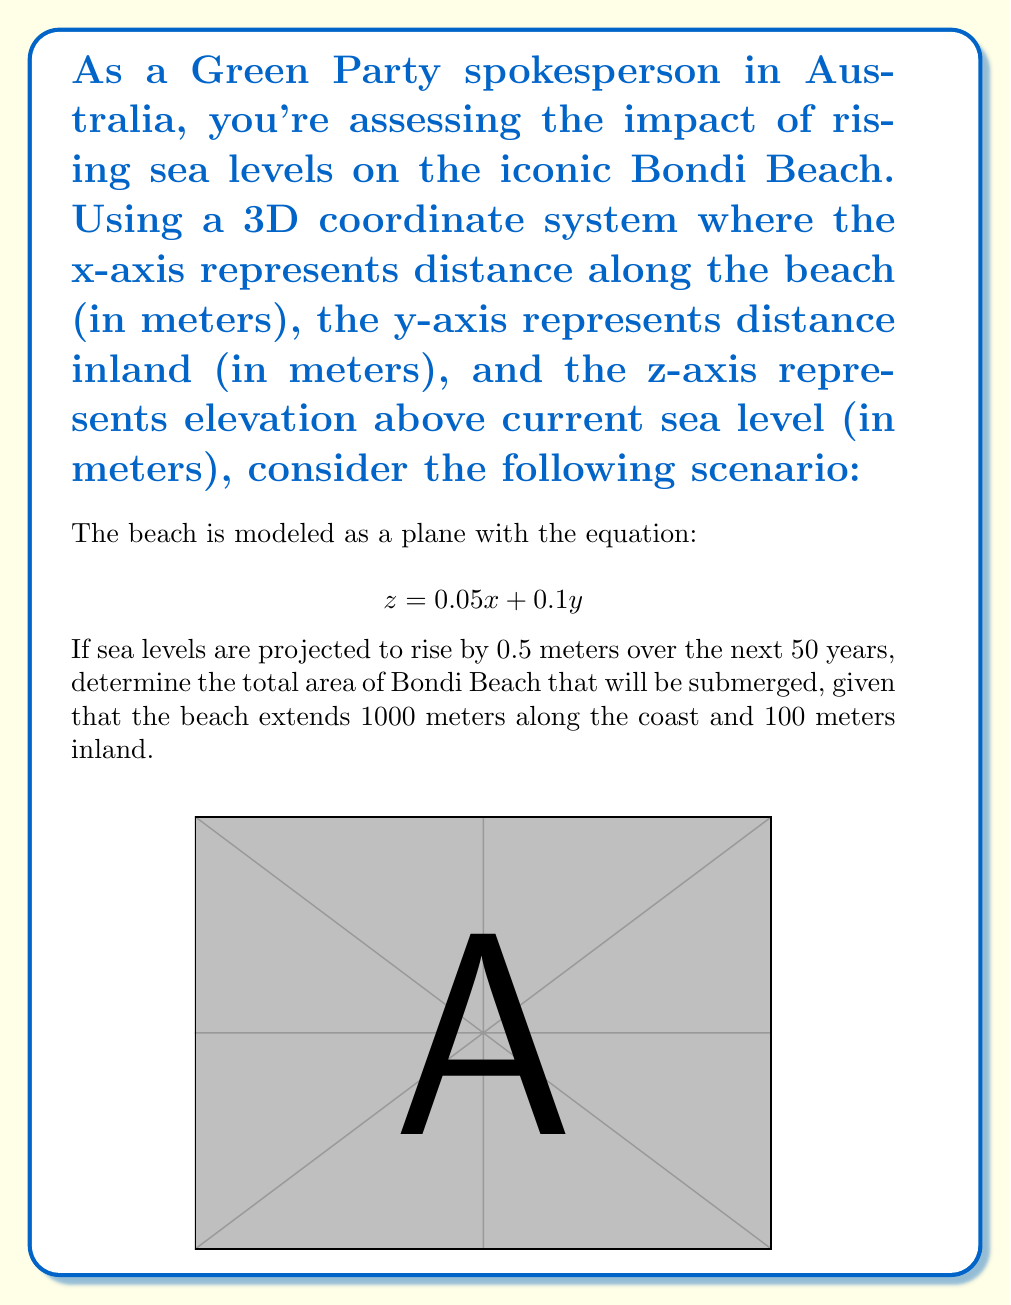Provide a solution to this math problem. Let's approach this step-by-step:

1) The current beach surface is given by the equation $z = 0.05x + 0.1y$. 

2) After the sea level rise, any point on the beach with $z \leq 0.5$ will be submerged.

3) To find the boundary of the submerged area, we set $z = 0.5$:

   $$ 0.5 = 0.05x + 0.1y $$

4) We need to find where this line intersects the boundaries of the beach. Let's check the x-axis (y = 0) and y-axis (x = 0) intersections:

   When y = 0: $0.5 = 0.05x$, so $x = 10$ meters
   When x = 0: $0.5 = 0.1y$, so $y = 5$ meters

5) This means the submerged area forms a right-angled triangle with:
   - Base (along x-axis) = 10 meters
   - Height (along y-axis) = 5 meters

6) The area of this triangle is:

   $$ A = \frac{1}{2} \times base \times height = \frac{1}{2} \times 10 \times 5 = 25 \text{ square meters} $$

7) However, this is only for a 1-meter wide strip of the beach. The beach extends 1000 meters along the coast.

8) Therefore, the total submerged area is:

   $$ 25 \text{ m}^2 \times 1000 \text{ m} = 25,000 \text{ square meters} $$
Answer: 25,000 m² 